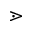<formula> <loc_0><loc_0><loc_500><loc_500>\gtrdot</formula> 